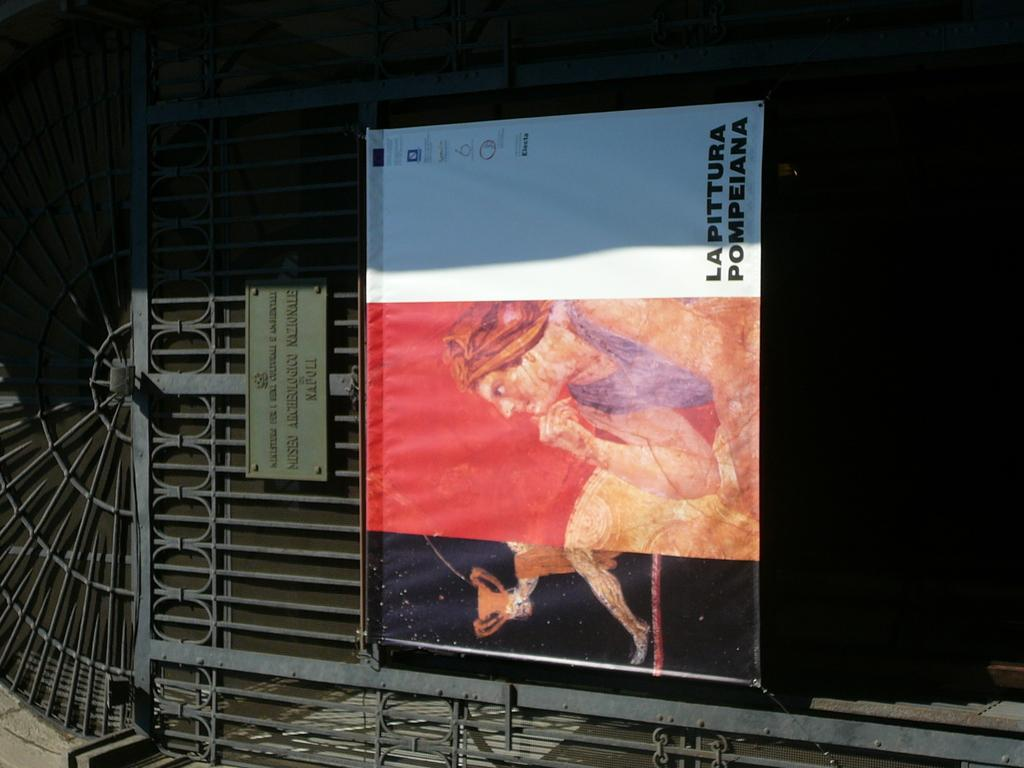<image>
Write a terse but informative summary of the picture. A poster of a woman and the words Lapittura Pompeiana hangs from a metal gate. 